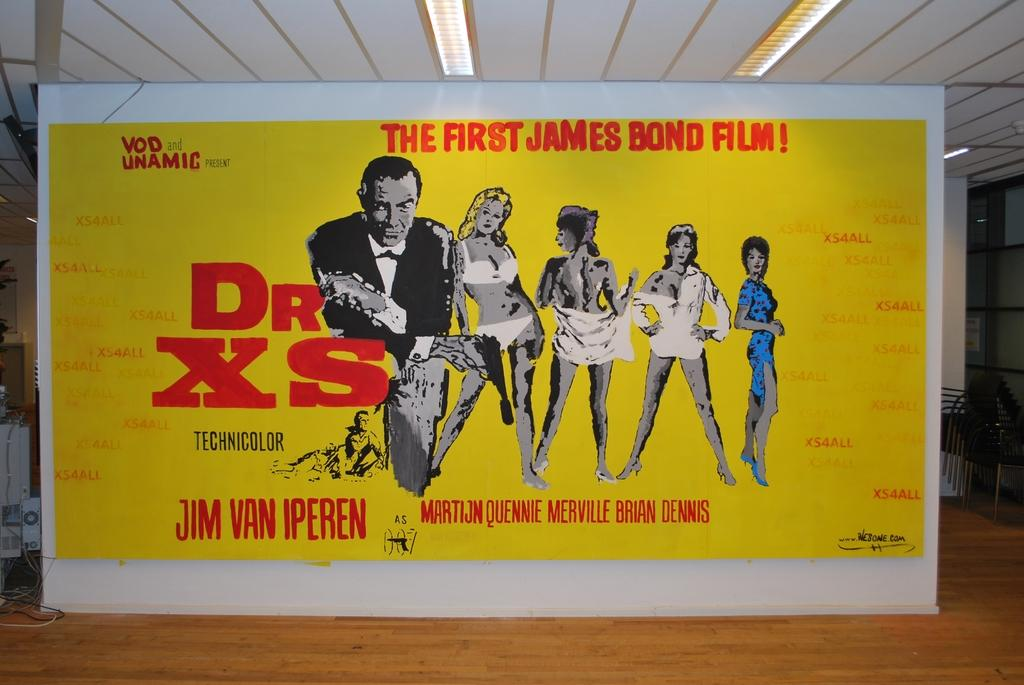<image>
Describe the image concisely. A poster for the first James Bond film, Dr. XS. 